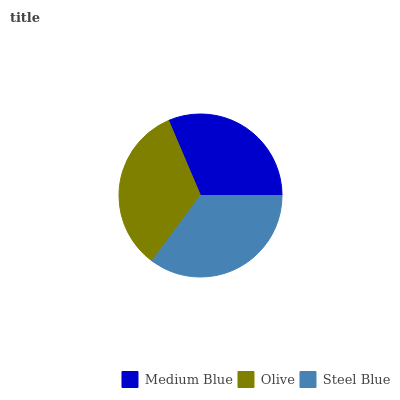Is Medium Blue the minimum?
Answer yes or no. Yes. Is Steel Blue the maximum?
Answer yes or no. Yes. Is Olive the minimum?
Answer yes or no. No. Is Olive the maximum?
Answer yes or no. No. Is Olive greater than Medium Blue?
Answer yes or no. Yes. Is Medium Blue less than Olive?
Answer yes or no. Yes. Is Medium Blue greater than Olive?
Answer yes or no. No. Is Olive less than Medium Blue?
Answer yes or no. No. Is Olive the high median?
Answer yes or no. Yes. Is Olive the low median?
Answer yes or no. Yes. Is Medium Blue the high median?
Answer yes or no. No. Is Steel Blue the low median?
Answer yes or no. No. 